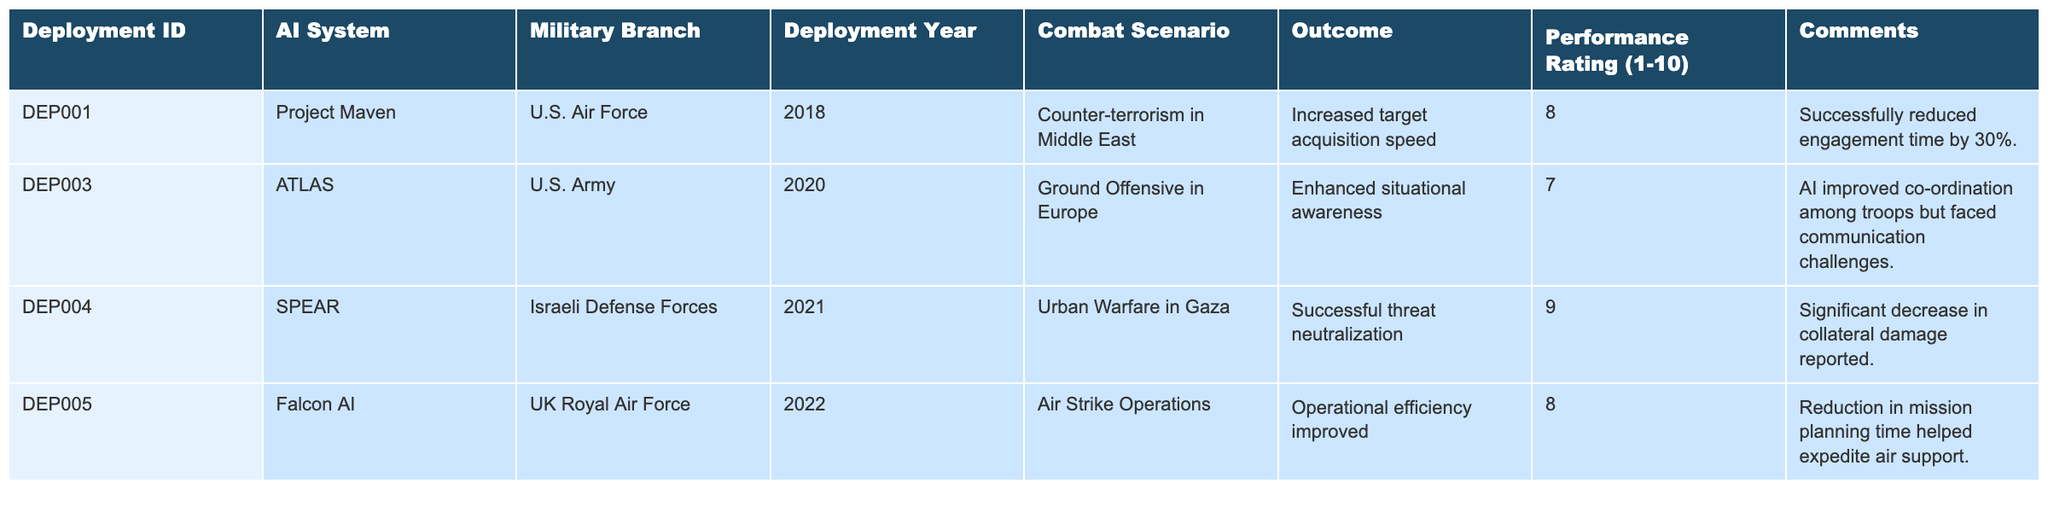What is the highest performance rating among the AI systems deployed? The table lists performance ratings for each deployment. The highest performance rating is 9, which corresponds to the SPEAR system used by the Israeli Defense Forces.
Answer: 9 How many different military branches are represented in the table? The table includes AI systems from four military branches: U.S. Air Force, U.S. Army, Israeli Defense Forces, and UK Royal Air Force.
Answer: 4 Which AI system was used for urban warfare in Gaza? According to the table, the SPEAR AI system was deployed for urban warfare in Gaza.
Answer: SPEAR What is the average performance rating of all deployments listed in the table? The performance ratings are 8, 7, 9, and 8 which sum to 32. There are four deployments, so the average rating is 32 divided by 4, resulting in an average of 8.
Answer: 8 Did any deployment have a performance rating below 7? From the table, the lowest performance rating is 7 for the ATLAS system, indicating that there are no deployments below this rating.
Answer: No What outcomes were achieved by the Falcon AI system deployed in air strike operations? The Falcon AI system improved operational efficiency, as noted in the outcome provided for its deployment in air strike operations.
Answer: Improved operational efficiency Which combat scenario had the highest performance rating recorded? The combat scenario of urban warfare in Gaza, with the SPEAR system, recorded the highest performance rating of 9. Therefore, this scenario had the highest rating.
Answer: Urban Warfare in Gaza Was the communication challenge noted as an issue for the ATLAS system? Yes, the comments indicate that while the AI improved coordination among troops, it faced communication challenges.
Answer: Yes Which deployment year had an AI system with a performance rating of 9? The table shows that the SPEAR system deployed in 2021 had a performance rating of 9.
Answer: 2021 What was the general impact of Project Maven on target acquisition speed? Project Maven's deployment resulted in increased target acquisition speed, reducing engagement time by 30%, as indicated in the comments.
Answer: Increased target acquisition speed Which military branch had the lowest-rated deployment? The table reveals that the U.S. Army deployment of the ATLAS system had the lowest rating of 7 among all deployments.
Answer: U.S. Army 